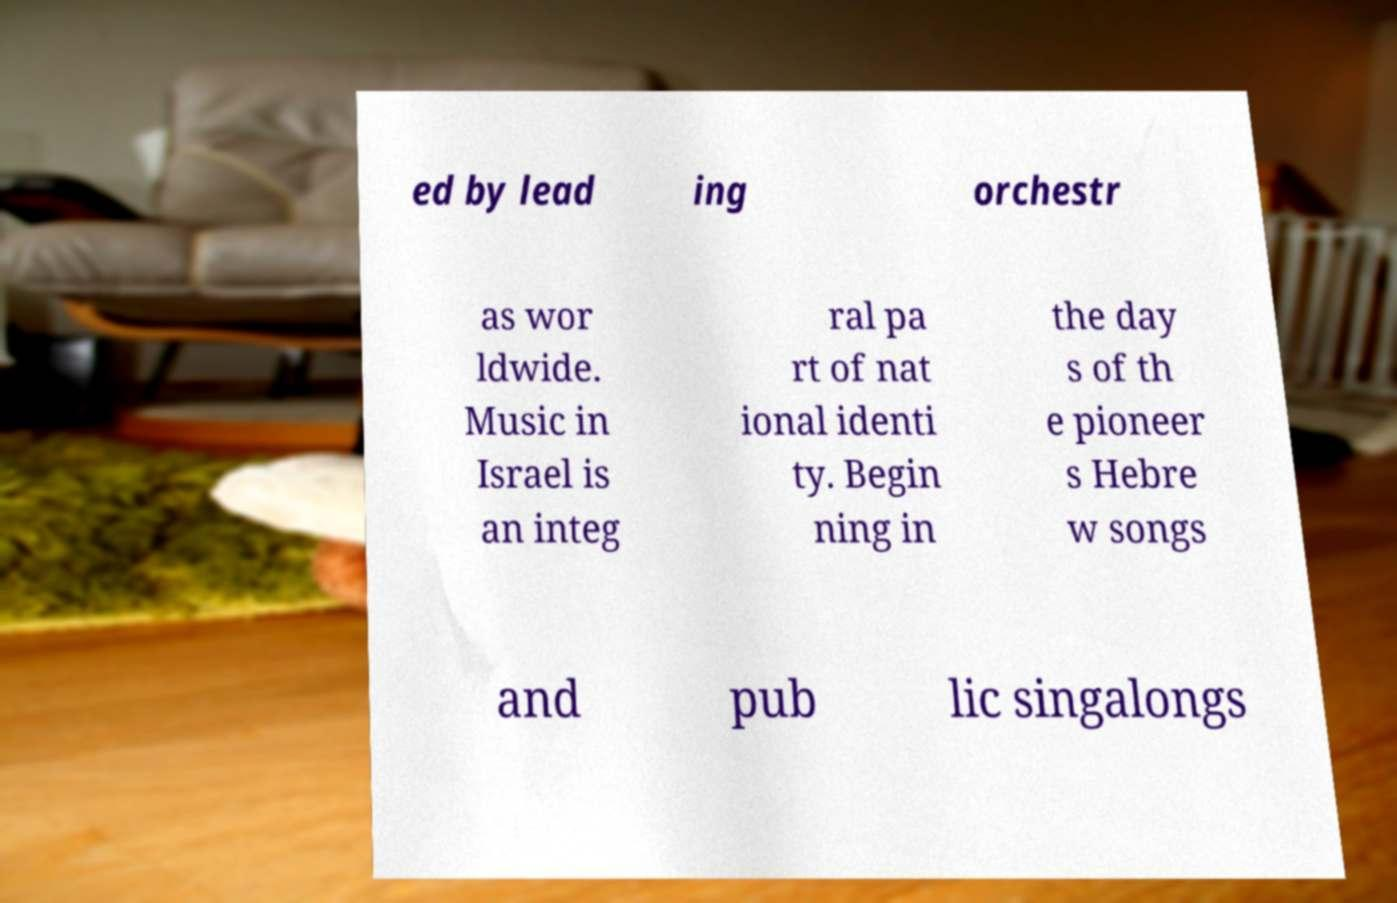Please read and relay the text visible in this image. What does it say? ed by lead ing orchestr as wor ldwide. Music in Israel is an integ ral pa rt of nat ional identi ty. Begin ning in the day s of th e pioneer s Hebre w songs and pub lic singalongs 